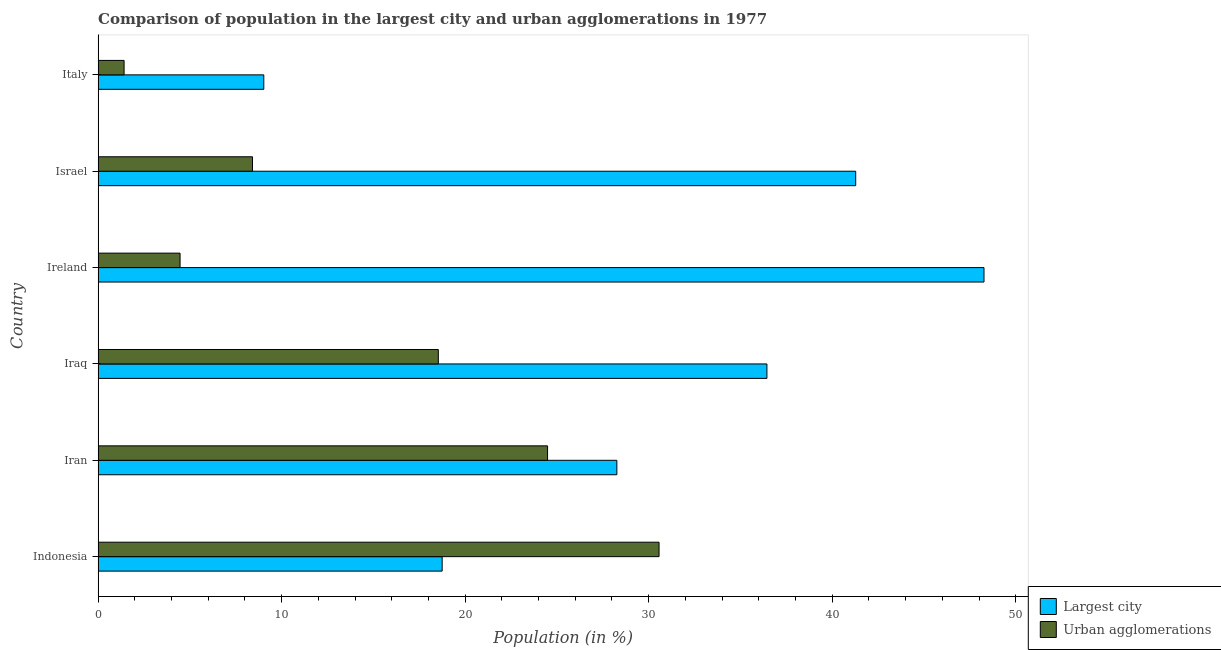Are the number of bars on each tick of the Y-axis equal?
Provide a short and direct response. Yes. How many bars are there on the 2nd tick from the bottom?
Offer a very short reply. 2. What is the label of the 6th group of bars from the top?
Provide a succinct answer. Indonesia. In how many cases, is the number of bars for a given country not equal to the number of legend labels?
Provide a short and direct response. 0. What is the population in the largest city in Italy?
Offer a very short reply. 9.03. Across all countries, what is the maximum population in urban agglomerations?
Give a very brief answer. 30.57. Across all countries, what is the minimum population in urban agglomerations?
Offer a terse response. 1.41. In which country was the population in the largest city maximum?
Ensure brevity in your answer.  Ireland. What is the total population in urban agglomerations in the graph?
Your answer should be compact. 87.89. What is the difference between the population in urban agglomerations in Israel and that in Italy?
Offer a terse response. 7. What is the difference between the population in urban agglomerations in Iran and the population in the largest city in Ireland?
Keep it short and to the point. -23.78. What is the average population in the largest city per country?
Provide a short and direct response. 30.34. What is the difference between the population in urban agglomerations and population in the largest city in Italy?
Ensure brevity in your answer.  -7.61. What is the ratio of the population in urban agglomerations in Ireland to that in Israel?
Offer a very short reply. 0.53. Is the difference between the population in urban agglomerations in Iraq and Italy greater than the difference between the population in the largest city in Iraq and Italy?
Provide a succinct answer. No. What is the difference between the highest and the second highest population in the largest city?
Provide a short and direct response. 6.99. What is the difference between the highest and the lowest population in the largest city?
Make the answer very short. 39.24. Is the sum of the population in the largest city in Indonesia and Iraq greater than the maximum population in urban agglomerations across all countries?
Offer a terse response. Yes. What does the 1st bar from the top in Indonesia represents?
Ensure brevity in your answer.  Urban agglomerations. What does the 1st bar from the bottom in Iraq represents?
Provide a succinct answer. Largest city. How many bars are there?
Ensure brevity in your answer.  12. Are all the bars in the graph horizontal?
Your answer should be compact. Yes. What is the difference between two consecutive major ticks on the X-axis?
Ensure brevity in your answer.  10. Does the graph contain any zero values?
Your response must be concise. No. Where does the legend appear in the graph?
Your answer should be compact. Bottom right. How are the legend labels stacked?
Provide a succinct answer. Vertical. What is the title of the graph?
Offer a very short reply. Comparison of population in the largest city and urban agglomerations in 1977. Does "Female" appear as one of the legend labels in the graph?
Give a very brief answer. No. What is the label or title of the Y-axis?
Give a very brief answer. Country. What is the Population (in %) of Largest city in Indonesia?
Keep it short and to the point. 18.75. What is the Population (in %) of Urban agglomerations in Indonesia?
Your answer should be compact. 30.57. What is the Population (in %) in Largest city in Iran?
Your answer should be very brief. 28.27. What is the Population (in %) of Urban agglomerations in Iran?
Offer a very short reply. 24.49. What is the Population (in %) of Largest city in Iraq?
Keep it short and to the point. 36.44. What is the Population (in %) of Urban agglomerations in Iraq?
Your answer should be very brief. 18.54. What is the Population (in %) of Largest city in Ireland?
Offer a terse response. 48.27. What is the Population (in %) in Urban agglomerations in Ireland?
Offer a terse response. 4.47. What is the Population (in %) of Largest city in Israel?
Keep it short and to the point. 41.28. What is the Population (in %) in Urban agglomerations in Israel?
Provide a short and direct response. 8.41. What is the Population (in %) in Largest city in Italy?
Provide a succinct answer. 9.03. What is the Population (in %) in Urban agglomerations in Italy?
Ensure brevity in your answer.  1.41. Across all countries, what is the maximum Population (in %) of Largest city?
Provide a short and direct response. 48.27. Across all countries, what is the maximum Population (in %) of Urban agglomerations?
Keep it short and to the point. 30.57. Across all countries, what is the minimum Population (in %) in Largest city?
Give a very brief answer. 9.03. Across all countries, what is the minimum Population (in %) of Urban agglomerations?
Offer a terse response. 1.41. What is the total Population (in %) in Largest city in the graph?
Your answer should be very brief. 182.03. What is the total Population (in %) in Urban agglomerations in the graph?
Provide a short and direct response. 87.89. What is the difference between the Population (in %) in Largest city in Indonesia and that in Iran?
Give a very brief answer. -9.52. What is the difference between the Population (in %) of Urban agglomerations in Indonesia and that in Iran?
Provide a succinct answer. 6.07. What is the difference between the Population (in %) in Largest city in Indonesia and that in Iraq?
Your answer should be compact. -17.7. What is the difference between the Population (in %) in Urban agglomerations in Indonesia and that in Iraq?
Offer a very short reply. 12.03. What is the difference between the Population (in %) of Largest city in Indonesia and that in Ireland?
Provide a short and direct response. -29.52. What is the difference between the Population (in %) in Urban agglomerations in Indonesia and that in Ireland?
Provide a succinct answer. 26.1. What is the difference between the Population (in %) of Largest city in Indonesia and that in Israel?
Provide a succinct answer. -22.53. What is the difference between the Population (in %) of Urban agglomerations in Indonesia and that in Israel?
Provide a succinct answer. 22.15. What is the difference between the Population (in %) in Largest city in Indonesia and that in Italy?
Provide a succinct answer. 9.72. What is the difference between the Population (in %) in Urban agglomerations in Indonesia and that in Italy?
Provide a succinct answer. 29.15. What is the difference between the Population (in %) in Largest city in Iran and that in Iraq?
Give a very brief answer. -8.18. What is the difference between the Population (in %) of Urban agglomerations in Iran and that in Iraq?
Make the answer very short. 5.95. What is the difference between the Population (in %) of Largest city in Iran and that in Ireland?
Your answer should be very brief. -20.01. What is the difference between the Population (in %) in Urban agglomerations in Iran and that in Ireland?
Ensure brevity in your answer.  20.02. What is the difference between the Population (in %) in Largest city in Iran and that in Israel?
Offer a very short reply. -13.01. What is the difference between the Population (in %) of Urban agglomerations in Iran and that in Israel?
Your response must be concise. 16.08. What is the difference between the Population (in %) in Largest city in Iran and that in Italy?
Provide a succinct answer. 19.24. What is the difference between the Population (in %) in Urban agglomerations in Iran and that in Italy?
Keep it short and to the point. 23.08. What is the difference between the Population (in %) of Largest city in Iraq and that in Ireland?
Your response must be concise. -11.83. What is the difference between the Population (in %) in Urban agglomerations in Iraq and that in Ireland?
Provide a short and direct response. 14.07. What is the difference between the Population (in %) of Largest city in Iraq and that in Israel?
Your response must be concise. -4.84. What is the difference between the Population (in %) of Urban agglomerations in Iraq and that in Israel?
Your answer should be very brief. 10.13. What is the difference between the Population (in %) of Largest city in Iraq and that in Italy?
Offer a very short reply. 27.42. What is the difference between the Population (in %) in Urban agglomerations in Iraq and that in Italy?
Your answer should be very brief. 17.12. What is the difference between the Population (in %) of Largest city in Ireland and that in Israel?
Ensure brevity in your answer.  6.99. What is the difference between the Population (in %) of Urban agglomerations in Ireland and that in Israel?
Offer a very short reply. -3.95. What is the difference between the Population (in %) in Largest city in Ireland and that in Italy?
Your answer should be compact. 39.24. What is the difference between the Population (in %) in Urban agglomerations in Ireland and that in Italy?
Make the answer very short. 3.05. What is the difference between the Population (in %) in Largest city in Israel and that in Italy?
Ensure brevity in your answer.  32.25. What is the difference between the Population (in %) of Urban agglomerations in Israel and that in Italy?
Provide a succinct answer. 7. What is the difference between the Population (in %) of Largest city in Indonesia and the Population (in %) of Urban agglomerations in Iran?
Provide a short and direct response. -5.74. What is the difference between the Population (in %) in Largest city in Indonesia and the Population (in %) in Urban agglomerations in Iraq?
Offer a very short reply. 0.21. What is the difference between the Population (in %) in Largest city in Indonesia and the Population (in %) in Urban agglomerations in Ireland?
Your response must be concise. 14.28. What is the difference between the Population (in %) of Largest city in Indonesia and the Population (in %) of Urban agglomerations in Israel?
Your answer should be very brief. 10.33. What is the difference between the Population (in %) in Largest city in Indonesia and the Population (in %) in Urban agglomerations in Italy?
Ensure brevity in your answer.  17.33. What is the difference between the Population (in %) in Largest city in Iran and the Population (in %) in Urban agglomerations in Iraq?
Offer a terse response. 9.73. What is the difference between the Population (in %) in Largest city in Iran and the Population (in %) in Urban agglomerations in Ireland?
Provide a short and direct response. 23.8. What is the difference between the Population (in %) in Largest city in Iran and the Population (in %) in Urban agglomerations in Israel?
Provide a short and direct response. 19.85. What is the difference between the Population (in %) of Largest city in Iran and the Population (in %) of Urban agglomerations in Italy?
Provide a succinct answer. 26.85. What is the difference between the Population (in %) of Largest city in Iraq and the Population (in %) of Urban agglomerations in Ireland?
Keep it short and to the point. 31.98. What is the difference between the Population (in %) in Largest city in Iraq and the Population (in %) in Urban agglomerations in Israel?
Make the answer very short. 28.03. What is the difference between the Population (in %) in Largest city in Iraq and the Population (in %) in Urban agglomerations in Italy?
Make the answer very short. 35.03. What is the difference between the Population (in %) of Largest city in Ireland and the Population (in %) of Urban agglomerations in Israel?
Provide a succinct answer. 39.86. What is the difference between the Population (in %) of Largest city in Ireland and the Population (in %) of Urban agglomerations in Italy?
Provide a short and direct response. 46.86. What is the difference between the Population (in %) in Largest city in Israel and the Population (in %) in Urban agglomerations in Italy?
Keep it short and to the point. 39.86. What is the average Population (in %) of Largest city per country?
Provide a succinct answer. 30.34. What is the average Population (in %) of Urban agglomerations per country?
Keep it short and to the point. 14.65. What is the difference between the Population (in %) of Largest city and Population (in %) of Urban agglomerations in Indonesia?
Offer a terse response. -11.82. What is the difference between the Population (in %) of Largest city and Population (in %) of Urban agglomerations in Iran?
Keep it short and to the point. 3.78. What is the difference between the Population (in %) of Largest city and Population (in %) of Urban agglomerations in Iraq?
Give a very brief answer. 17.9. What is the difference between the Population (in %) in Largest city and Population (in %) in Urban agglomerations in Ireland?
Your answer should be very brief. 43.81. What is the difference between the Population (in %) in Largest city and Population (in %) in Urban agglomerations in Israel?
Offer a terse response. 32.87. What is the difference between the Population (in %) of Largest city and Population (in %) of Urban agglomerations in Italy?
Your answer should be very brief. 7.61. What is the ratio of the Population (in %) of Largest city in Indonesia to that in Iran?
Ensure brevity in your answer.  0.66. What is the ratio of the Population (in %) of Urban agglomerations in Indonesia to that in Iran?
Your answer should be compact. 1.25. What is the ratio of the Population (in %) of Largest city in Indonesia to that in Iraq?
Your answer should be compact. 0.51. What is the ratio of the Population (in %) of Urban agglomerations in Indonesia to that in Iraq?
Make the answer very short. 1.65. What is the ratio of the Population (in %) in Largest city in Indonesia to that in Ireland?
Your response must be concise. 0.39. What is the ratio of the Population (in %) of Urban agglomerations in Indonesia to that in Ireland?
Offer a very short reply. 6.84. What is the ratio of the Population (in %) of Largest city in Indonesia to that in Israel?
Your response must be concise. 0.45. What is the ratio of the Population (in %) in Urban agglomerations in Indonesia to that in Israel?
Offer a terse response. 3.63. What is the ratio of the Population (in %) in Largest city in Indonesia to that in Italy?
Keep it short and to the point. 2.08. What is the ratio of the Population (in %) in Urban agglomerations in Indonesia to that in Italy?
Give a very brief answer. 21.6. What is the ratio of the Population (in %) in Largest city in Iran to that in Iraq?
Keep it short and to the point. 0.78. What is the ratio of the Population (in %) in Urban agglomerations in Iran to that in Iraq?
Make the answer very short. 1.32. What is the ratio of the Population (in %) of Largest city in Iran to that in Ireland?
Provide a succinct answer. 0.59. What is the ratio of the Population (in %) of Urban agglomerations in Iran to that in Ireland?
Keep it short and to the point. 5.48. What is the ratio of the Population (in %) in Largest city in Iran to that in Israel?
Your answer should be very brief. 0.68. What is the ratio of the Population (in %) in Urban agglomerations in Iran to that in Israel?
Your answer should be very brief. 2.91. What is the ratio of the Population (in %) of Largest city in Iran to that in Italy?
Ensure brevity in your answer.  3.13. What is the ratio of the Population (in %) of Urban agglomerations in Iran to that in Italy?
Your response must be concise. 17.31. What is the ratio of the Population (in %) in Largest city in Iraq to that in Ireland?
Ensure brevity in your answer.  0.76. What is the ratio of the Population (in %) of Urban agglomerations in Iraq to that in Ireland?
Give a very brief answer. 4.15. What is the ratio of the Population (in %) of Largest city in Iraq to that in Israel?
Keep it short and to the point. 0.88. What is the ratio of the Population (in %) of Urban agglomerations in Iraq to that in Israel?
Offer a terse response. 2.2. What is the ratio of the Population (in %) of Largest city in Iraq to that in Italy?
Offer a very short reply. 4.04. What is the ratio of the Population (in %) in Urban agglomerations in Iraq to that in Italy?
Keep it short and to the point. 13.1. What is the ratio of the Population (in %) of Largest city in Ireland to that in Israel?
Provide a succinct answer. 1.17. What is the ratio of the Population (in %) in Urban agglomerations in Ireland to that in Israel?
Give a very brief answer. 0.53. What is the ratio of the Population (in %) of Largest city in Ireland to that in Italy?
Your answer should be very brief. 5.35. What is the ratio of the Population (in %) in Urban agglomerations in Ireland to that in Italy?
Provide a succinct answer. 3.16. What is the ratio of the Population (in %) of Largest city in Israel to that in Italy?
Offer a very short reply. 4.57. What is the ratio of the Population (in %) in Urban agglomerations in Israel to that in Italy?
Make the answer very short. 5.94. What is the difference between the highest and the second highest Population (in %) in Largest city?
Your response must be concise. 6.99. What is the difference between the highest and the second highest Population (in %) in Urban agglomerations?
Give a very brief answer. 6.07. What is the difference between the highest and the lowest Population (in %) of Largest city?
Your response must be concise. 39.24. What is the difference between the highest and the lowest Population (in %) in Urban agglomerations?
Give a very brief answer. 29.15. 